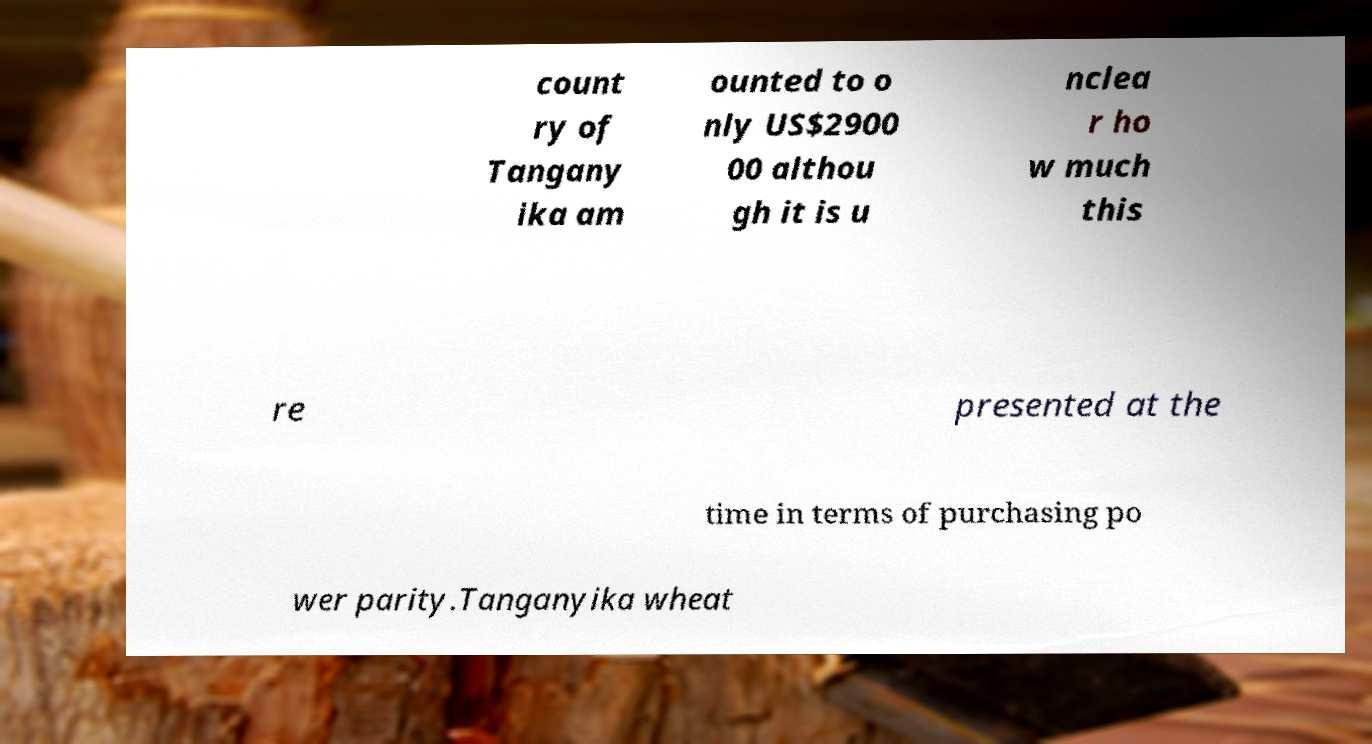Can you read and provide the text displayed in the image?This photo seems to have some interesting text. Can you extract and type it out for me? count ry of Tangany ika am ounted to o nly US$2900 00 althou gh it is u nclea r ho w much this re presented at the time in terms of purchasing po wer parity.Tanganyika wheat 